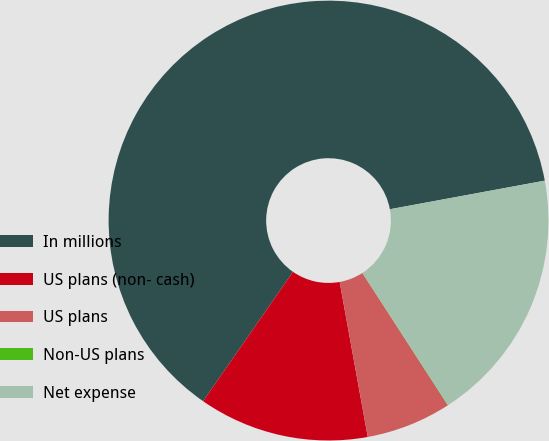Convert chart to OTSL. <chart><loc_0><loc_0><loc_500><loc_500><pie_chart><fcel>In millions<fcel>US plans (non- cash)<fcel>US plans<fcel>Non-US plans<fcel>Net expense<nl><fcel>62.43%<fcel>12.51%<fcel>6.27%<fcel>0.03%<fcel>18.75%<nl></chart> 